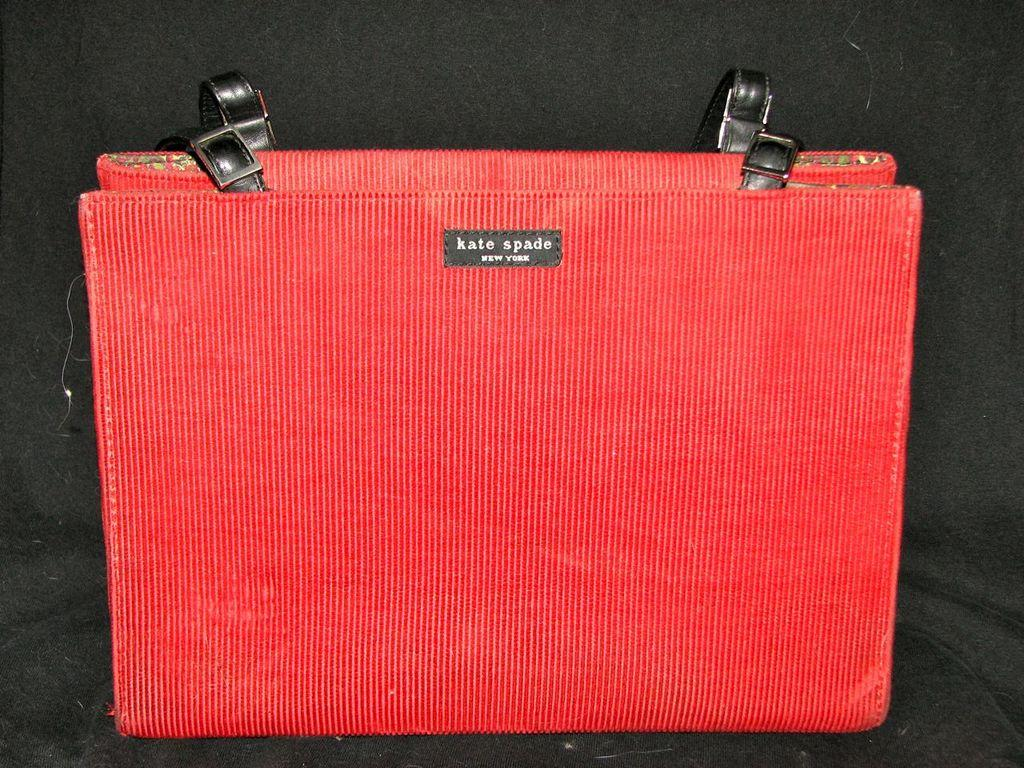What color is the bag in the image? The bag in the image is red. What brand is the bag associated with? The bag has the text "Kate spade" on it. What can be seen in the background of the image? There is a black color sofa in the background of the image. What type of paint is being used to create the baseball in the image? There is no baseball present in the image, so it is not possible to determine what type of paint is being used. 